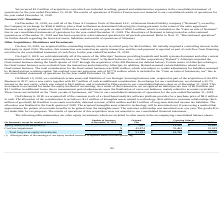According to Allscripts Healthcare Solutions's financial document, For what amount was the outstanding minority interests in a third party acquired? According to the financial document, $6.9 million. The relevant text states: "utstanding minority interests in a third party for $6.9 million. We initially acquired a controlling interest in the..." Also, On which date was the assets of the Allscripts’ business sold? According to the financial document, April 2, 2018. The relevant text states: "On April 2, 2018, we sold substantially all of the assets of the Allscripts’ business providing hospitals and health..." Also, What was the total consideration for OneContent business? According to the financial document, $260 million. The relevant text states: "otal consideration for the OneContent business was $260 million, which was subject to certain adjustments for liabilities assumed by Hyland and net working capital..." Also, can you calculate: What is the change in the Equity method investments from 2018 to 2019? Based on the calculation: 11,332 - 10,667, the result is 665 (in thousands). This is based on the information: "quity method investments (1) 5 $ 7,407 $ 11,332 $ 10,667 Equity method investments (1) 5 $ 7,407 $ 11,332 $ 10,667..." The key data points involved are: 10,667, 11,332. Also, can you calculate: What is the average Cost less impairment for 2018 and 2019? To answer this question, I need to perform calculations using the financial data. The calculation is: (32,462 + 25,923) / 2, which equals 29192.5 (in thousands). This is based on the information: "Cost less impairment 9 43,874 32,462 25,923 Cost less impairment 9 43,874 32,462 25,923..." The key data points involved are: 25,923, 32,462. Also, can you calculate: What is the change in the Total long-term equity investments from 2018 to 2019? Based on the calculation: 43,794 - 36,590, the result is 7204 (in thousands). This is based on the information: "ng-term equity investments 14 $ 51,281 $ 43,794 $ 36,590 Total long-term equity investments 14 $ 51,281 $ 43,794 $ 36,590..." The key data points involved are: 36,590, 43,794. 